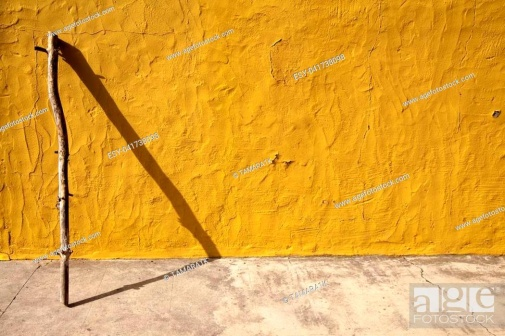What feelings or emotions does this image evoke for you? This image evokes a sense of tranquility and contemplation. The simplistic and solitary nature of the stick against the vibrant yellow background, accompanied by the stark shadow, might elicit introspection or a feeling of solitude. The scene’s minimalism and the intense color contrast can also invoke thoughts of resilience and the persistence of nature. Is there a story behind this image you might imagine? Imagine an elderly man, once a vibrant traveler, now leaves his beloved walking stick leaning against the wall of his modest, sunlit home. Each groove and imperfection on the stick tells a of countless adventures traversed through dense forests and rugged mountains. He sits nearby, reminiscing about his journey, each memory unfolding in the shadows cast by the setting sun. The stick, now still and quiet, symbolizes the peace he has found in stillness after a lifetime of motion. 